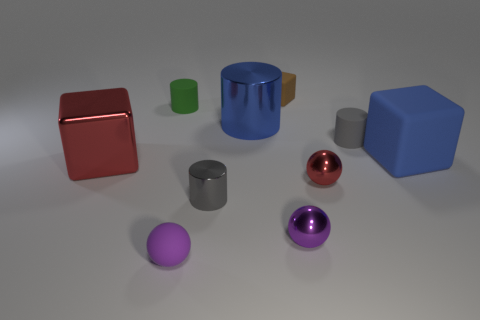I'm curious about the materials, which objects look metallic and which are not? From the appearance in the image, the big red cube and the small reflective sphere seem to have a metallic sheen, indicating that they might be metallic. The rest of the objects, due to their diffuse surfaces, generally appear to be non-metallic, possibly plastic or rubber. 